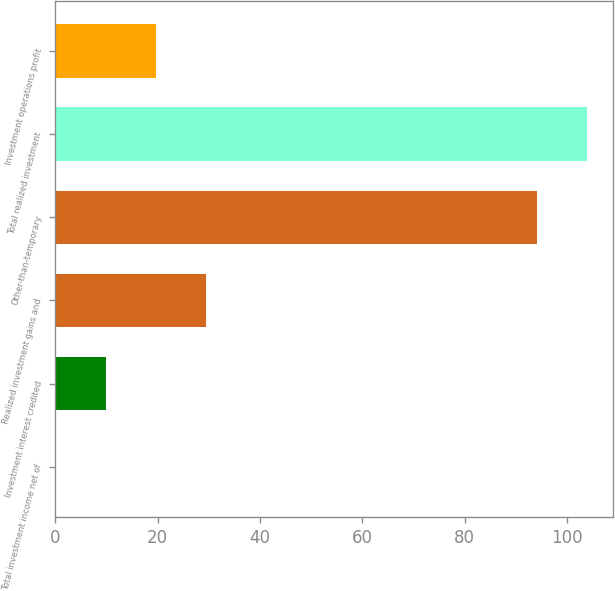Convert chart. <chart><loc_0><loc_0><loc_500><loc_500><bar_chart><fcel>Total investment income net of<fcel>Investment interest credited<fcel>Realized investment gains and<fcel>Other-than-temporary<fcel>Total realized investment<fcel>Investment operations profit<nl><fcel>0.13<fcel>9.92<fcel>29.5<fcel>94<fcel>103.79<fcel>19.71<nl></chart> 